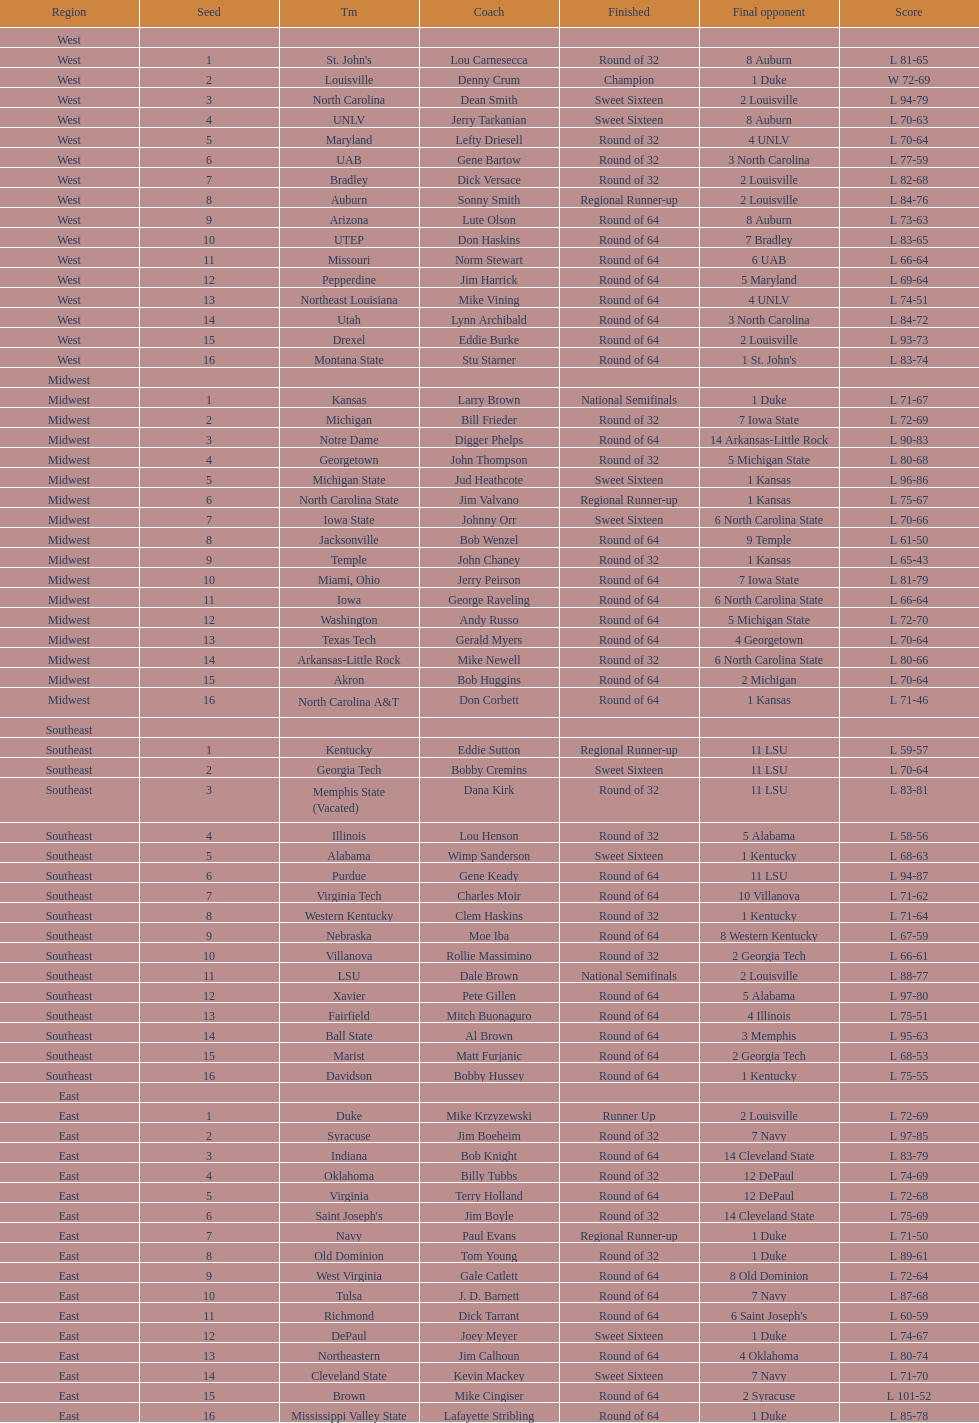How many teams are in the east region. 16. 